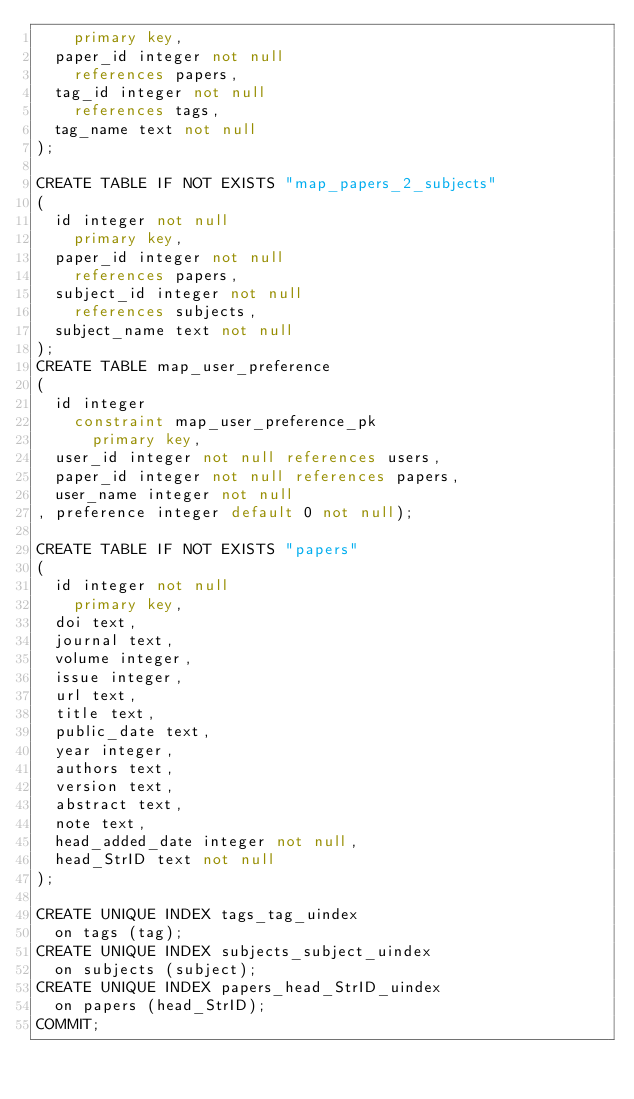Convert code to text. <code><loc_0><loc_0><loc_500><loc_500><_SQL_>		primary key,
	paper_id integer not null
		references papers,
	tag_id integer not null
		references tags,
	tag_name text not null
);

CREATE TABLE IF NOT EXISTS "map_papers_2_subjects"
(
	id integer not null
		primary key,
	paper_id integer not null
		references papers,
	subject_id integer not null
		references subjects,
	subject_name text not null
);
CREATE TABLE map_user_preference
(
	id integer
		constraint map_user_preference_pk
			primary key,
	user_id integer not null references users,
	paper_id integer not null references papers,
	user_name integer not null
, preference integer default 0 not null);

CREATE TABLE IF NOT EXISTS "papers"
(
	id integer not null
		primary key,
	doi text,
	journal text,
	volume integer,
	issue integer,
	url text,
	title text,
	public_date text,
	year integer,
	authors text,
	version text,
	abstract text,
	note text,
	head_added_date integer not null,
	head_StrID text not null
);

CREATE UNIQUE INDEX tags_tag_uindex
	on tags (tag);
CREATE UNIQUE INDEX subjects_subject_uindex
	on subjects (subject);
CREATE UNIQUE INDEX papers_head_StrID_uindex
	on papers (head_StrID);
COMMIT;
</code> 